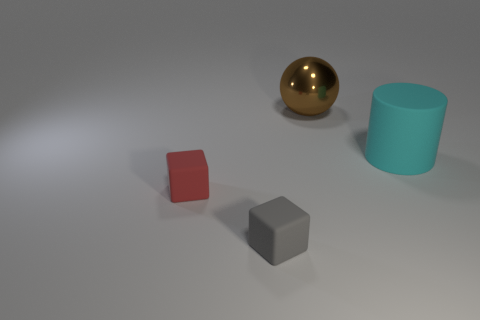There is a rubber thing that is to the right of the big thing left of the large matte object; how big is it?
Your response must be concise. Large. What is the shape of the object that is behind the object that is to the right of the large thing behind the big cyan object?
Ensure brevity in your answer.  Sphere. The cyan cylinder that is made of the same material as the red cube is what size?
Ensure brevity in your answer.  Large. Is the number of gray matte objects greater than the number of large green metallic cylinders?
Keep it short and to the point. Yes. What is the material of the other object that is the same size as the gray thing?
Your response must be concise. Rubber. Do the cube to the right of the red thing and the shiny thing have the same size?
Offer a very short reply. No. How many cylinders are either cyan rubber objects or red rubber things?
Make the answer very short. 1. What material is the large object right of the big brown thing?
Keep it short and to the point. Rubber. Are there fewer big cyan cylinders than big purple rubber cylinders?
Your answer should be very brief. No. What is the size of the thing that is behind the gray matte cube and on the left side of the large metallic thing?
Offer a very short reply. Small. 